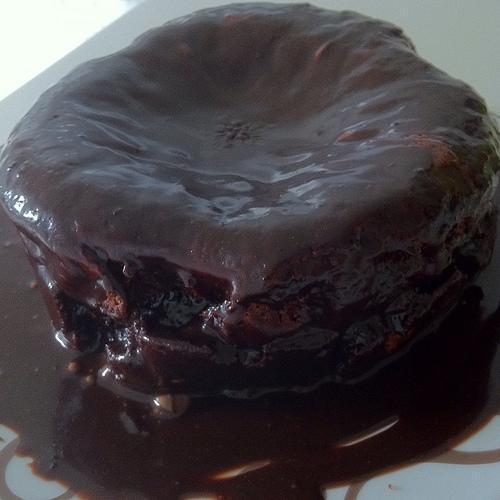How many edible items are shown?
Give a very brief answer. 1. 